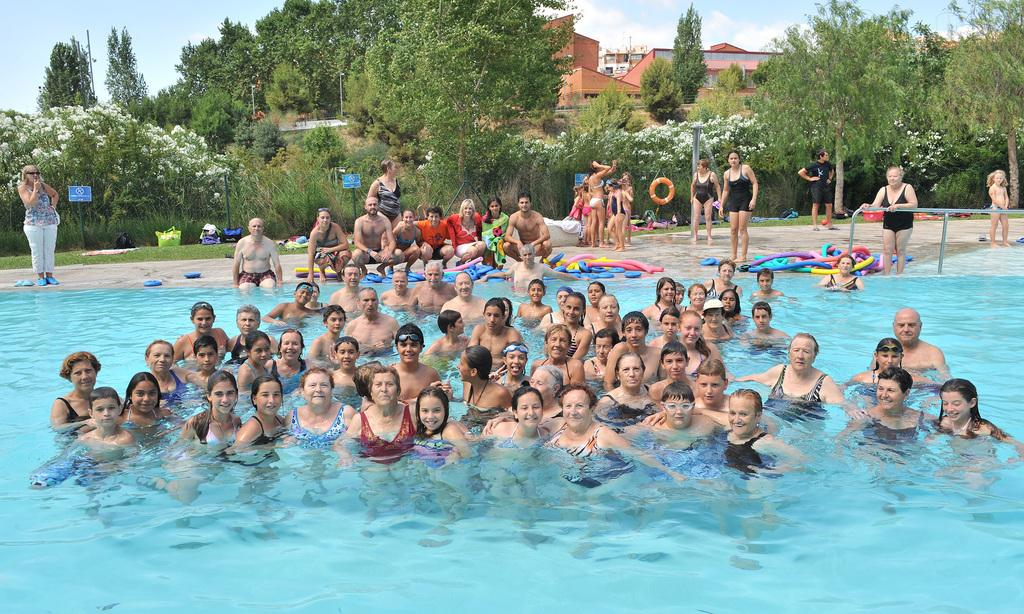What is the main subject of the image? The main subject of the image is people in a swimming pool. What can be seen in the background of the image? There are trees and buildings in the background of the image. What is visible at the bottom of the image? There is water visible at the bottom of the image. What statement can be seen written on the skin of the people in the image? There is no statement written on the skin of the people in the image. Can you see any goldfish swimming in the water at the bottom of the image? There are no goldfish visible in the water at the bottom of the image; it is likely the water in the swimming pool. 